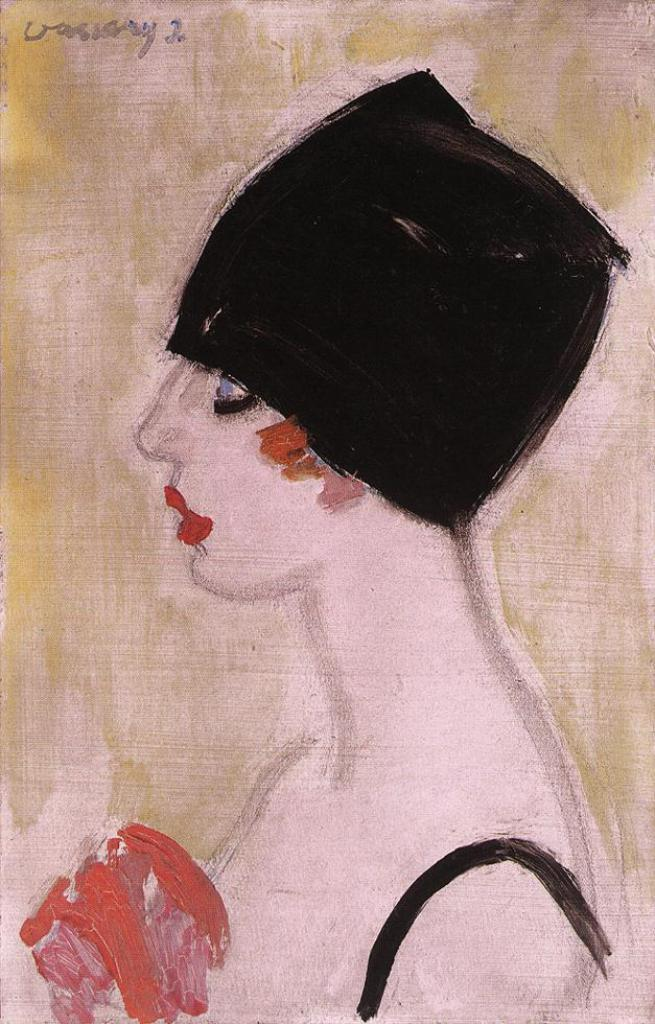What is the main subject of the image? The main subject of the image is a painting of a woman. What else can be seen in the image besides the painting? There is text in the image. What type of eggnog is being served in the painting? There is no eggnog present in the image, as it is a painting of a woman and not a scene involving food or drink. 